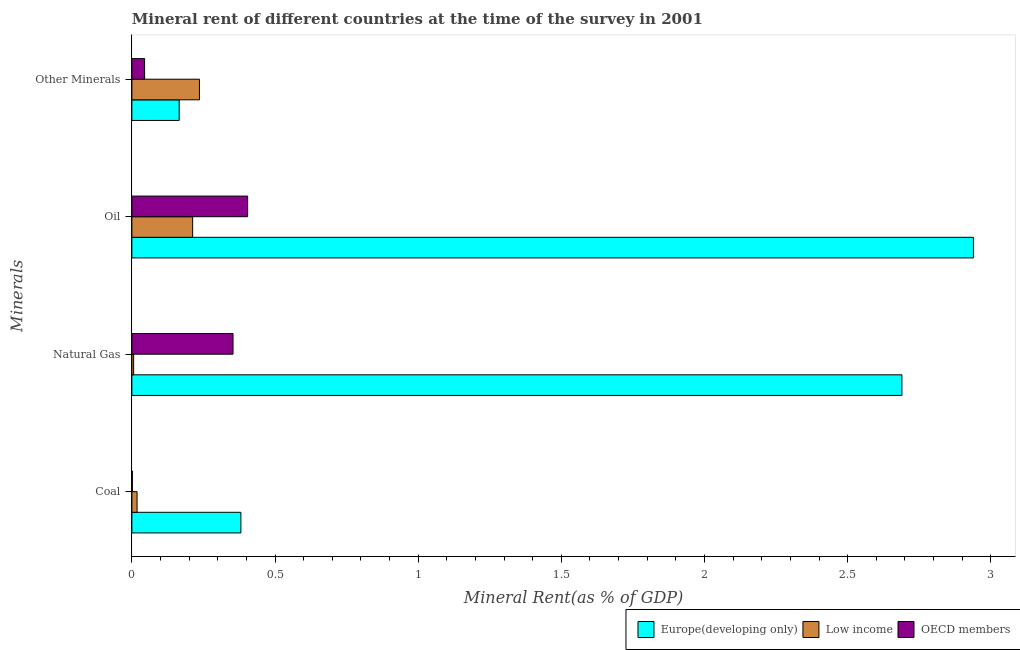Are the number of bars on each tick of the Y-axis equal?
Offer a terse response. Yes. How many bars are there on the 2nd tick from the bottom?
Provide a succinct answer. 3. What is the label of the 2nd group of bars from the top?
Offer a very short reply. Oil. What is the oil rent in OECD members?
Give a very brief answer. 0.4. Across all countries, what is the maximum coal rent?
Your answer should be compact. 0.38. Across all countries, what is the minimum coal rent?
Your response must be concise. 0. In which country was the oil rent maximum?
Make the answer very short. Europe(developing only). In which country was the oil rent minimum?
Provide a short and direct response. Low income. What is the total natural gas rent in the graph?
Offer a very short reply. 3.05. What is the difference between the natural gas rent in Europe(developing only) and that in OECD members?
Give a very brief answer. 2.34. What is the difference between the  rent of other minerals in Low income and the natural gas rent in OECD members?
Your response must be concise. -0.12. What is the average  rent of other minerals per country?
Give a very brief answer. 0.15. What is the difference between the oil rent and  rent of other minerals in Europe(developing only)?
Your answer should be compact. 2.77. In how many countries, is the  rent of other minerals greater than 1.2 %?
Make the answer very short. 0. What is the ratio of the oil rent in Low income to that in OECD members?
Provide a short and direct response. 0.53. Is the difference between the natural gas rent in OECD members and Europe(developing only) greater than the difference between the coal rent in OECD members and Europe(developing only)?
Give a very brief answer. No. What is the difference between the highest and the second highest natural gas rent?
Provide a succinct answer. 2.34. What is the difference between the highest and the lowest natural gas rent?
Your answer should be very brief. 2.68. In how many countries, is the oil rent greater than the average oil rent taken over all countries?
Ensure brevity in your answer.  1. Is the sum of the natural gas rent in Europe(developing only) and OECD members greater than the maximum oil rent across all countries?
Your answer should be very brief. Yes. Is it the case that in every country, the sum of the coal rent and oil rent is greater than the sum of  rent of other minerals and natural gas rent?
Ensure brevity in your answer.  No. Is it the case that in every country, the sum of the coal rent and natural gas rent is greater than the oil rent?
Offer a terse response. No. How many bars are there?
Offer a very short reply. 12. Does the graph contain any zero values?
Ensure brevity in your answer.  No. Does the graph contain grids?
Your answer should be compact. No. Where does the legend appear in the graph?
Offer a terse response. Bottom right. How are the legend labels stacked?
Ensure brevity in your answer.  Horizontal. What is the title of the graph?
Offer a terse response. Mineral rent of different countries at the time of the survey in 2001. Does "Andorra" appear as one of the legend labels in the graph?
Provide a short and direct response. No. What is the label or title of the X-axis?
Your answer should be compact. Mineral Rent(as % of GDP). What is the label or title of the Y-axis?
Offer a very short reply. Minerals. What is the Mineral Rent(as % of GDP) of Europe(developing only) in Coal?
Offer a very short reply. 0.38. What is the Mineral Rent(as % of GDP) of Low income in Coal?
Provide a succinct answer. 0.02. What is the Mineral Rent(as % of GDP) of OECD members in Coal?
Provide a short and direct response. 0. What is the Mineral Rent(as % of GDP) of Europe(developing only) in Natural Gas?
Ensure brevity in your answer.  2.69. What is the Mineral Rent(as % of GDP) in Low income in Natural Gas?
Ensure brevity in your answer.  0.01. What is the Mineral Rent(as % of GDP) of OECD members in Natural Gas?
Provide a short and direct response. 0.35. What is the Mineral Rent(as % of GDP) of Europe(developing only) in Oil?
Offer a terse response. 2.94. What is the Mineral Rent(as % of GDP) in Low income in Oil?
Ensure brevity in your answer.  0.21. What is the Mineral Rent(as % of GDP) in OECD members in Oil?
Offer a very short reply. 0.4. What is the Mineral Rent(as % of GDP) of Europe(developing only) in Other Minerals?
Your answer should be compact. 0.17. What is the Mineral Rent(as % of GDP) of Low income in Other Minerals?
Provide a succinct answer. 0.24. What is the Mineral Rent(as % of GDP) of OECD members in Other Minerals?
Provide a succinct answer. 0.04. Across all Minerals, what is the maximum Mineral Rent(as % of GDP) in Europe(developing only)?
Keep it short and to the point. 2.94. Across all Minerals, what is the maximum Mineral Rent(as % of GDP) in Low income?
Offer a terse response. 0.24. Across all Minerals, what is the maximum Mineral Rent(as % of GDP) of OECD members?
Ensure brevity in your answer.  0.4. Across all Minerals, what is the minimum Mineral Rent(as % of GDP) of Europe(developing only)?
Your answer should be very brief. 0.17. Across all Minerals, what is the minimum Mineral Rent(as % of GDP) of Low income?
Offer a very short reply. 0.01. Across all Minerals, what is the minimum Mineral Rent(as % of GDP) in OECD members?
Give a very brief answer. 0. What is the total Mineral Rent(as % of GDP) in Europe(developing only) in the graph?
Your answer should be compact. 6.17. What is the total Mineral Rent(as % of GDP) in Low income in the graph?
Make the answer very short. 0.47. What is the total Mineral Rent(as % of GDP) of OECD members in the graph?
Provide a succinct answer. 0.8. What is the difference between the Mineral Rent(as % of GDP) in Europe(developing only) in Coal and that in Natural Gas?
Make the answer very short. -2.31. What is the difference between the Mineral Rent(as % of GDP) in Low income in Coal and that in Natural Gas?
Your response must be concise. 0.01. What is the difference between the Mineral Rent(as % of GDP) of OECD members in Coal and that in Natural Gas?
Your response must be concise. -0.35. What is the difference between the Mineral Rent(as % of GDP) in Europe(developing only) in Coal and that in Oil?
Your answer should be very brief. -2.56. What is the difference between the Mineral Rent(as % of GDP) of Low income in Coal and that in Oil?
Keep it short and to the point. -0.19. What is the difference between the Mineral Rent(as % of GDP) of OECD members in Coal and that in Oil?
Provide a short and direct response. -0.4. What is the difference between the Mineral Rent(as % of GDP) of Europe(developing only) in Coal and that in Other Minerals?
Provide a succinct answer. 0.22. What is the difference between the Mineral Rent(as % of GDP) in Low income in Coal and that in Other Minerals?
Your answer should be very brief. -0.22. What is the difference between the Mineral Rent(as % of GDP) of OECD members in Coal and that in Other Minerals?
Your response must be concise. -0.04. What is the difference between the Mineral Rent(as % of GDP) of Europe(developing only) in Natural Gas and that in Oil?
Provide a succinct answer. -0.25. What is the difference between the Mineral Rent(as % of GDP) of Low income in Natural Gas and that in Oil?
Offer a terse response. -0.21. What is the difference between the Mineral Rent(as % of GDP) of OECD members in Natural Gas and that in Oil?
Provide a succinct answer. -0.05. What is the difference between the Mineral Rent(as % of GDP) in Europe(developing only) in Natural Gas and that in Other Minerals?
Ensure brevity in your answer.  2.52. What is the difference between the Mineral Rent(as % of GDP) of Low income in Natural Gas and that in Other Minerals?
Ensure brevity in your answer.  -0.23. What is the difference between the Mineral Rent(as % of GDP) in OECD members in Natural Gas and that in Other Minerals?
Ensure brevity in your answer.  0.31. What is the difference between the Mineral Rent(as % of GDP) in Europe(developing only) in Oil and that in Other Minerals?
Offer a very short reply. 2.77. What is the difference between the Mineral Rent(as % of GDP) of Low income in Oil and that in Other Minerals?
Keep it short and to the point. -0.02. What is the difference between the Mineral Rent(as % of GDP) of OECD members in Oil and that in Other Minerals?
Provide a succinct answer. 0.36. What is the difference between the Mineral Rent(as % of GDP) of Europe(developing only) in Coal and the Mineral Rent(as % of GDP) of Low income in Natural Gas?
Offer a terse response. 0.37. What is the difference between the Mineral Rent(as % of GDP) of Europe(developing only) in Coal and the Mineral Rent(as % of GDP) of OECD members in Natural Gas?
Make the answer very short. 0.03. What is the difference between the Mineral Rent(as % of GDP) in Low income in Coal and the Mineral Rent(as % of GDP) in OECD members in Natural Gas?
Ensure brevity in your answer.  -0.34. What is the difference between the Mineral Rent(as % of GDP) in Europe(developing only) in Coal and the Mineral Rent(as % of GDP) in Low income in Oil?
Keep it short and to the point. 0.17. What is the difference between the Mineral Rent(as % of GDP) of Europe(developing only) in Coal and the Mineral Rent(as % of GDP) of OECD members in Oil?
Your response must be concise. -0.02. What is the difference between the Mineral Rent(as % of GDP) in Low income in Coal and the Mineral Rent(as % of GDP) in OECD members in Oil?
Keep it short and to the point. -0.39. What is the difference between the Mineral Rent(as % of GDP) of Europe(developing only) in Coal and the Mineral Rent(as % of GDP) of Low income in Other Minerals?
Your answer should be very brief. 0.14. What is the difference between the Mineral Rent(as % of GDP) in Europe(developing only) in Coal and the Mineral Rent(as % of GDP) in OECD members in Other Minerals?
Offer a terse response. 0.34. What is the difference between the Mineral Rent(as % of GDP) of Low income in Coal and the Mineral Rent(as % of GDP) of OECD members in Other Minerals?
Keep it short and to the point. -0.03. What is the difference between the Mineral Rent(as % of GDP) in Europe(developing only) in Natural Gas and the Mineral Rent(as % of GDP) in Low income in Oil?
Provide a short and direct response. 2.48. What is the difference between the Mineral Rent(as % of GDP) of Europe(developing only) in Natural Gas and the Mineral Rent(as % of GDP) of OECD members in Oil?
Give a very brief answer. 2.29. What is the difference between the Mineral Rent(as % of GDP) of Low income in Natural Gas and the Mineral Rent(as % of GDP) of OECD members in Oil?
Offer a terse response. -0.4. What is the difference between the Mineral Rent(as % of GDP) in Europe(developing only) in Natural Gas and the Mineral Rent(as % of GDP) in Low income in Other Minerals?
Your answer should be very brief. 2.45. What is the difference between the Mineral Rent(as % of GDP) in Europe(developing only) in Natural Gas and the Mineral Rent(as % of GDP) in OECD members in Other Minerals?
Offer a terse response. 2.65. What is the difference between the Mineral Rent(as % of GDP) of Low income in Natural Gas and the Mineral Rent(as % of GDP) of OECD members in Other Minerals?
Your answer should be compact. -0.04. What is the difference between the Mineral Rent(as % of GDP) in Europe(developing only) in Oil and the Mineral Rent(as % of GDP) in Low income in Other Minerals?
Your answer should be very brief. 2.7. What is the difference between the Mineral Rent(as % of GDP) of Europe(developing only) in Oil and the Mineral Rent(as % of GDP) of OECD members in Other Minerals?
Offer a terse response. 2.89. What is the difference between the Mineral Rent(as % of GDP) in Low income in Oil and the Mineral Rent(as % of GDP) in OECD members in Other Minerals?
Offer a terse response. 0.17. What is the average Mineral Rent(as % of GDP) in Europe(developing only) per Minerals?
Make the answer very short. 1.54. What is the average Mineral Rent(as % of GDP) in Low income per Minerals?
Provide a succinct answer. 0.12. What is the average Mineral Rent(as % of GDP) in OECD members per Minerals?
Provide a short and direct response. 0.2. What is the difference between the Mineral Rent(as % of GDP) in Europe(developing only) and Mineral Rent(as % of GDP) in Low income in Coal?
Make the answer very short. 0.36. What is the difference between the Mineral Rent(as % of GDP) in Europe(developing only) and Mineral Rent(as % of GDP) in OECD members in Coal?
Your answer should be very brief. 0.38. What is the difference between the Mineral Rent(as % of GDP) of Low income and Mineral Rent(as % of GDP) of OECD members in Coal?
Your answer should be very brief. 0.02. What is the difference between the Mineral Rent(as % of GDP) in Europe(developing only) and Mineral Rent(as % of GDP) in Low income in Natural Gas?
Your answer should be compact. 2.68. What is the difference between the Mineral Rent(as % of GDP) in Europe(developing only) and Mineral Rent(as % of GDP) in OECD members in Natural Gas?
Provide a succinct answer. 2.34. What is the difference between the Mineral Rent(as % of GDP) in Low income and Mineral Rent(as % of GDP) in OECD members in Natural Gas?
Keep it short and to the point. -0.35. What is the difference between the Mineral Rent(as % of GDP) of Europe(developing only) and Mineral Rent(as % of GDP) of Low income in Oil?
Offer a terse response. 2.73. What is the difference between the Mineral Rent(as % of GDP) of Europe(developing only) and Mineral Rent(as % of GDP) of OECD members in Oil?
Keep it short and to the point. 2.53. What is the difference between the Mineral Rent(as % of GDP) of Low income and Mineral Rent(as % of GDP) of OECD members in Oil?
Your answer should be compact. -0.19. What is the difference between the Mineral Rent(as % of GDP) in Europe(developing only) and Mineral Rent(as % of GDP) in Low income in Other Minerals?
Provide a short and direct response. -0.07. What is the difference between the Mineral Rent(as % of GDP) of Europe(developing only) and Mineral Rent(as % of GDP) of OECD members in Other Minerals?
Offer a terse response. 0.12. What is the difference between the Mineral Rent(as % of GDP) in Low income and Mineral Rent(as % of GDP) in OECD members in Other Minerals?
Offer a terse response. 0.19. What is the ratio of the Mineral Rent(as % of GDP) in Europe(developing only) in Coal to that in Natural Gas?
Make the answer very short. 0.14. What is the ratio of the Mineral Rent(as % of GDP) of Low income in Coal to that in Natural Gas?
Ensure brevity in your answer.  2.92. What is the ratio of the Mineral Rent(as % of GDP) of OECD members in Coal to that in Natural Gas?
Make the answer very short. 0.01. What is the ratio of the Mineral Rent(as % of GDP) of Europe(developing only) in Coal to that in Oil?
Offer a very short reply. 0.13. What is the ratio of the Mineral Rent(as % of GDP) in Low income in Coal to that in Oil?
Offer a very short reply. 0.09. What is the ratio of the Mineral Rent(as % of GDP) of OECD members in Coal to that in Oil?
Your answer should be very brief. 0. What is the ratio of the Mineral Rent(as % of GDP) in Europe(developing only) in Coal to that in Other Minerals?
Your response must be concise. 2.3. What is the ratio of the Mineral Rent(as % of GDP) in Low income in Coal to that in Other Minerals?
Keep it short and to the point. 0.08. What is the ratio of the Mineral Rent(as % of GDP) of OECD members in Coal to that in Other Minerals?
Provide a short and direct response. 0.04. What is the ratio of the Mineral Rent(as % of GDP) of Europe(developing only) in Natural Gas to that in Oil?
Ensure brevity in your answer.  0.92. What is the ratio of the Mineral Rent(as % of GDP) in Low income in Natural Gas to that in Oil?
Your answer should be very brief. 0.03. What is the ratio of the Mineral Rent(as % of GDP) in OECD members in Natural Gas to that in Oil?
Provide a succinct answer. 0.87. What is the ratio of the Mineral Rent(as % of GDP) of Europe(developing only) in Natural Gas to that in Other Minerals?
Provide a succinct answer. 16.27. What is the ratio of the Mineral Rent(as % of GDP) in Low income in Natural Gas to that in Other Minerals?
Provide a short and direct response. 0.03. What is the ratio of the Mineral Rent(as % of GDP) in OECD members in Natural Gas to that in Other Minerals?
Offer a very short reply. 7.95. What is the ratio of the Mineral Rent(as % of GDP) in Europe(developing only) in Oil to that in Other Minerals?
Keep it short and to the point. 17.78. What is the ratio of the Mineral Rent(as % of GDP) of Low income in Oil to that in Other Minerals?
Your answer should be very brief. 0.9. What is the ratio of the Mineral Rent(as % of GDP) of OECD members in Oil to that in Other Minerals?
Provide a short and direct response. 9.1. What is the difference between the highest and the second highest Mineral Rent(as % of GDP) of Europe(developing only)?
Offer a terse response. 0.25. What is the difference between the highest and the second highest Mineral Rent(as % of GDP) of Low income?
Ensure brevity in your answer.  0.02. What is the difference between the highest and the second highest Mineral Rent(as % of GDP) of OECD members?
Your response must be concise. 0.05. What is the difference between the highest and the lowest Mineral Rent(as % of GDP) of Europe(developing only)?
Provide a short and direct response. 2.77. What is the difference between the highest and the lowest Mineral Rent(as % of GDP) in Low income?
Ensure brevity in your answer.  0.23. What is the difference between the highest and the lowest Mineral Rent(as % of GDP) in OECD members?
Give a very brief answer. 0.4. 